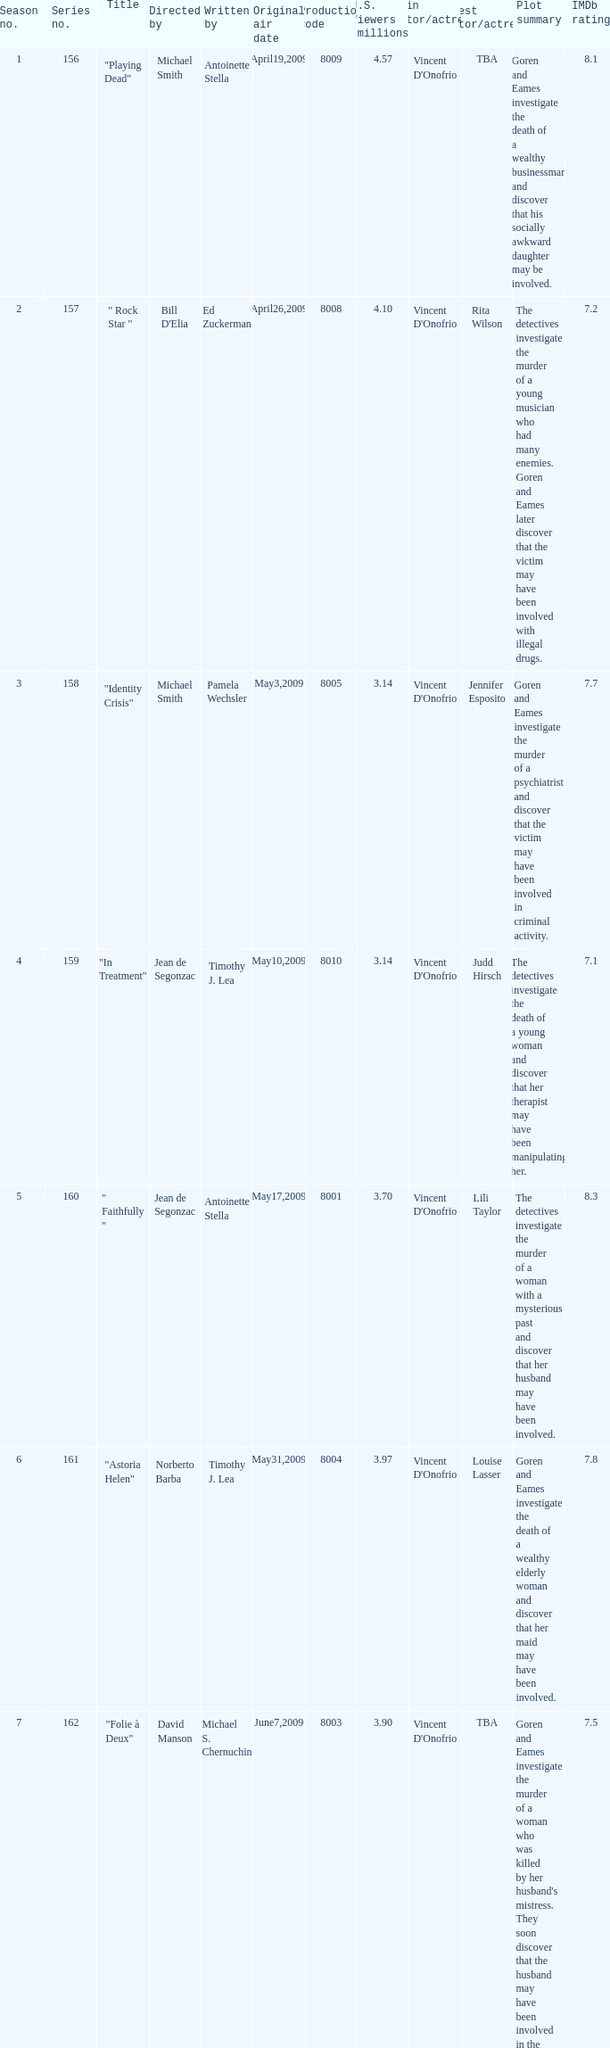Which is the biggest production code? 8014.0. 